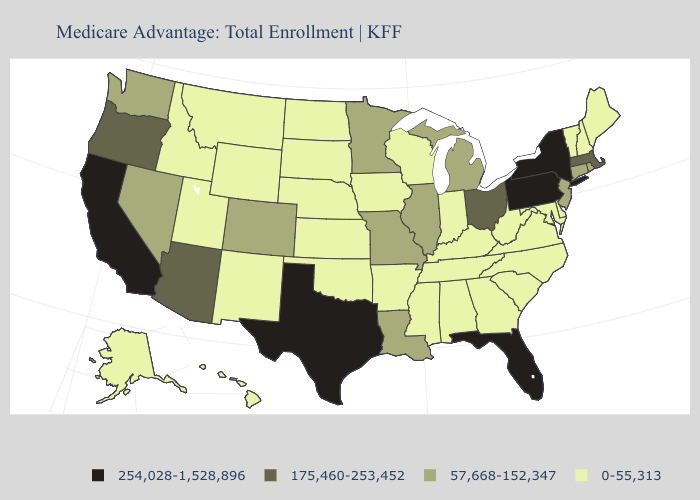Does Pennsylvania have the same value as New York?
Concise answer only. Yes. Name the states that have a value in the range 175,460-253,452?
Quick response, please. Arizona, Massachusetts, Ohio, Oregon. Does the first symbol in the legend represent the smallest category?
Be succinct. No. What is the value of New Mexico?
Give a very brief answer. 0-55,313. Does New Mexico have a higher value than Wyoming?
Answer briefly. No. Which states have the lowest value in the West?
Concise answer only. Alaska, Hawaii, Idaho, Montana, New Mexico, Utah, Wyoming. Which states have the lowest value in the South?
Concise answer only. Alabama, Arkansas, Delaware, Georgia, Kentucky, Maryland, Mississippi, North Carolina, Oklahoma, South Carolina, Tennessee, Virginia, West Virginia. Among the states that border South Carolina , which have the lowest value?
Be succinct. Georgia, North Carolina. Name the states that have a value in the range 0-55,313?
Write a very short answer. Alaska, Alabama, Arkansas, Delaware, Georgia, Hawaii, Iowa, Idaho, Indiana, Kansas, Kentucky, Maryland, Maine, Mississippi, Montana, North Carolina, North Dakota, Nebraska, New Hampshire, New Mexico, Oklahoma, South Carolina, South Dakota, Tennessee, Utah, Virginia, Vermont, Wisconsin, West Virginia, Wyoming. Does the map have missing data?
Give a very brief answer. No. Does Virginia have the same value as Alabama?
Give a very brief answer. Yes. Name the states that have a value in the range 175,460-253,452?
Quick response, please. Arizona, Massachusetts, Ohio, Oregon. What is the value of Maine?
Quick response, please. 0-55,313. Which states have the lowest value in the West?
Write a very short answer. Alaska, Hawaii, Idaho, Montana, New Mexico, Utah, Wyoming. How many symbols are there in the legend?
Short answer required. 4. 